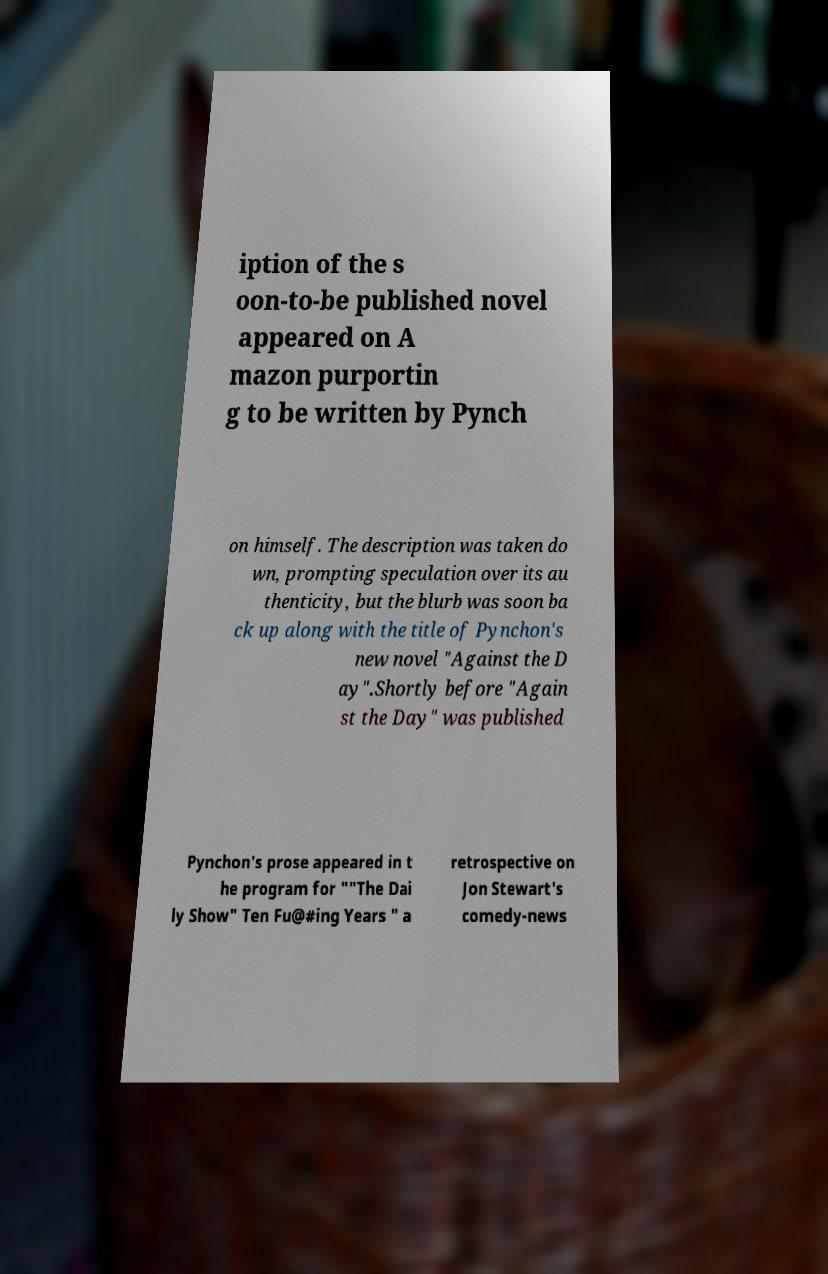Please read and relay the text visible in this image. What does it say? iption of the s oon-to-be published novel appeared on A mazon purportin g to be written by Pynch on himself. The description was taken do wn, prompting speculation over its au thenticity, but the blurb was soon ba ck up along with the title of Pynchon's new novel "Against the D ay".Shortly before "Again st the Day" was published Pynchon's prose appeared in t he program for ""The Dai ly Show" Ten Fu@#ing Years " a retrospective on Jon Stewart's comedy-news 